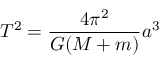Convert formula to latex. <formula><loc_0><loc_0><loc_500><loc_500>T ^ { 2 } = { \frac { 4 \pi ^ { 2 } } { G ( M + m ) } } a ^ { 3 }</formula> 